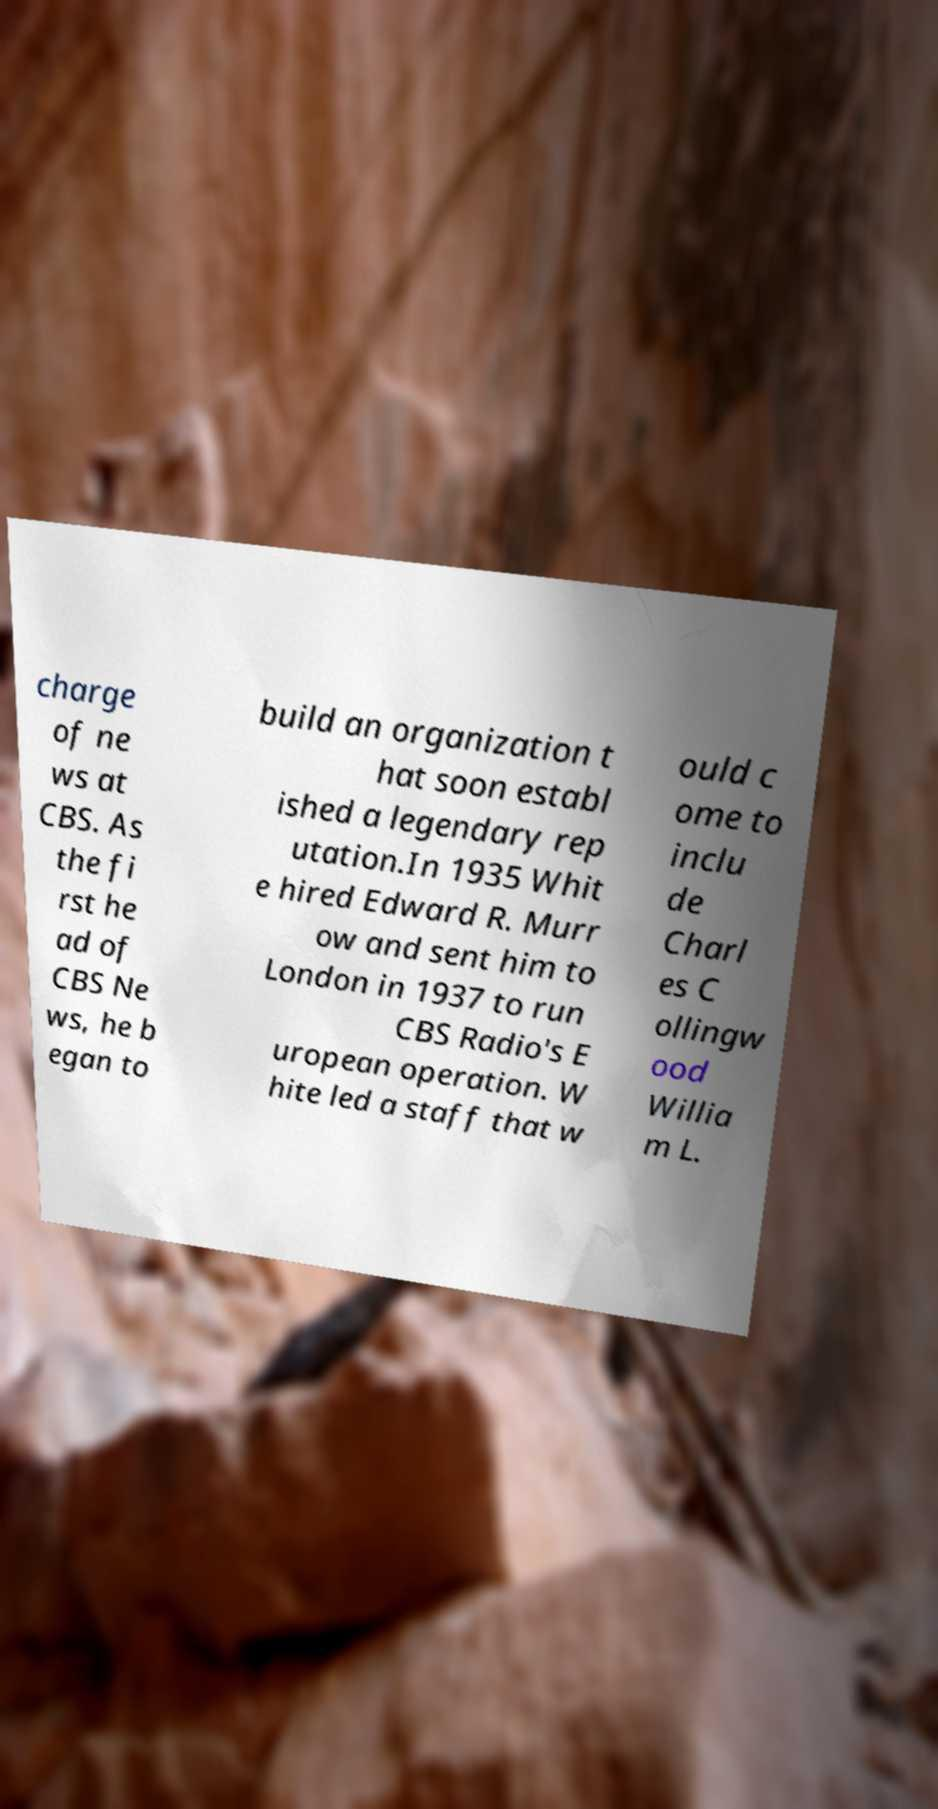I need the written content from this picture converted into text. Can you do that? charge of ne ws at CBS. As the fi rst he ad of CBS Ne ws, he b egan to build an organization t hat soon establ ished a legendary rep utation.In 1935 Whit e hired Edward R. Murr ow and sent him to London in 1937 to run CBS Radio's E uropean operation. W hite led a staff that w ould c ome to inclu de Charl es C ollingw ood Willia m L. 